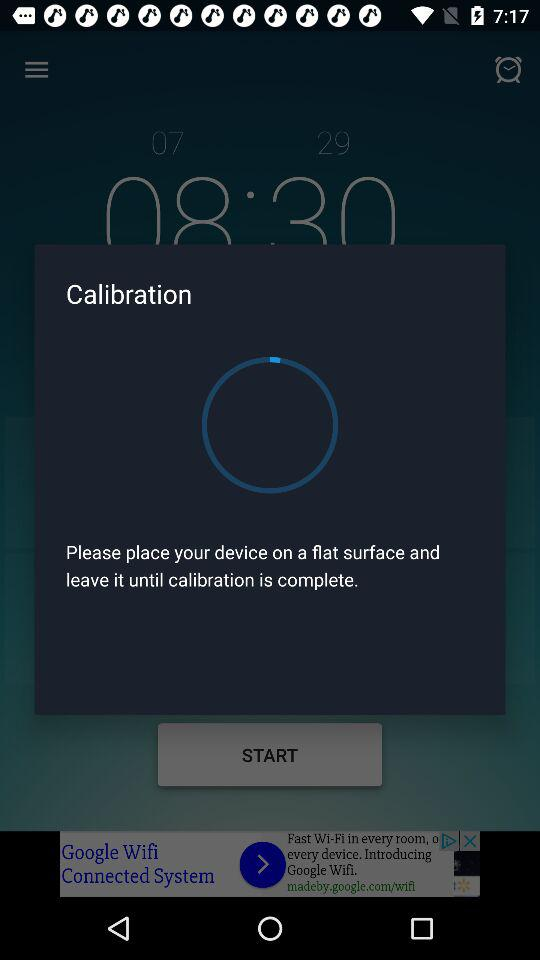What percentage of my sleep was efficient?
Answer the question using a single word or phrase. 74% 